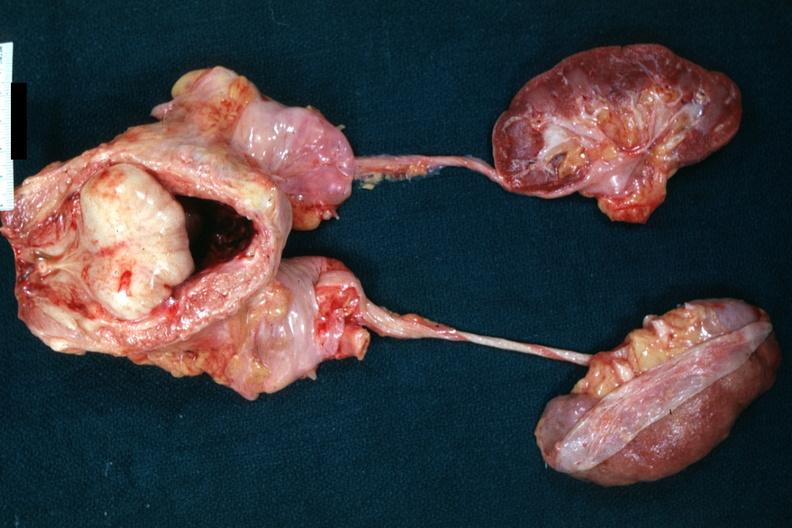what does this image show?
Answer the question using a single word or phrase. Massively enlarge nodular prostate with median lobe protrusion into floor of bladder 